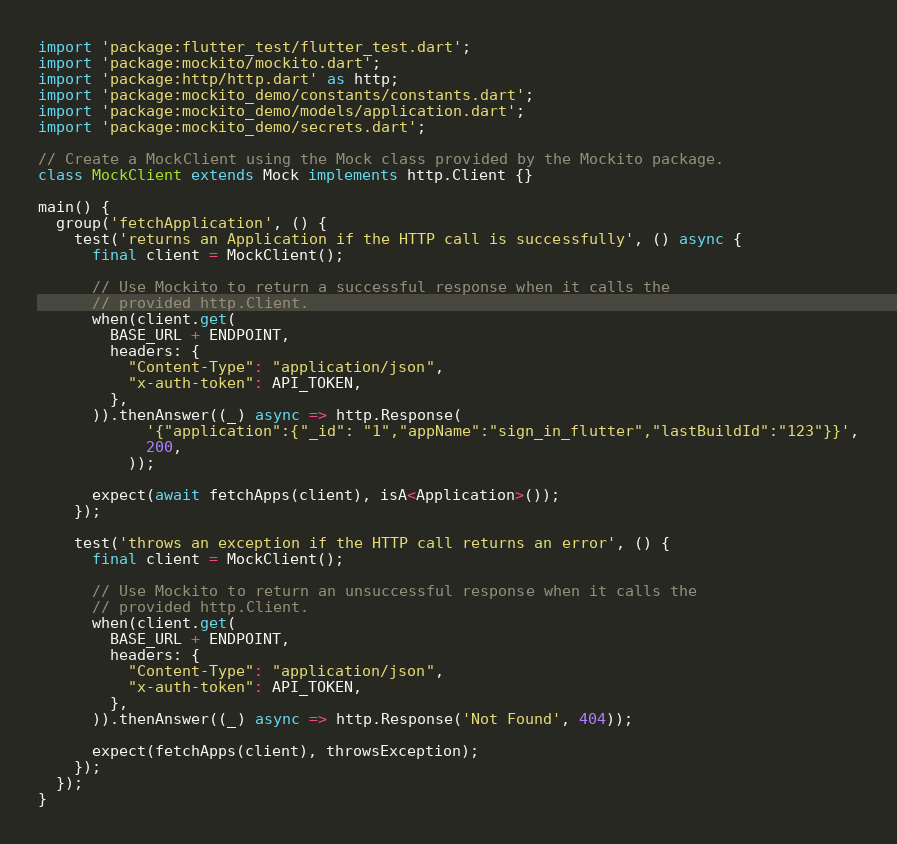<code> <loc_0><loc_0><loc_500><loc_500><_Dart_>import 'package:flutter_test/flutter_test.dart';
import 'package:mockito/mockito.dart';
import 'package:http/http.dart' as http;
import 'package:mockito_demo/constants/constants.dart';
import 'package:mockito_demo/models/application.dart';
import 'package:mockito_demo/secrets.dart';

// Create a MockClient using the Mock class provided by the Mockito package.
class MockClient extends Mock implements http.Client {}

main() {
  group('fetchApplication', () {
    test('returns an Application if the HTTP call is successfully', () async {
      final client = MockClient();

      // Use Mockito to return a successful response when it calls the
      // provided http.Client.
      when(client.get(
        BASE_URL + ENDPOINT,
        headers: {
          "Content-Type": "application/json",
          "x-auth-token": API_TOKEN,
        },
      )).thenAnswer((_) async => http.Response(
            '{"application":{"_id": "1","appName":"sign_in_flutter","lastBuildId":"123"}}',
            200,
          ));

      expect(await fetchApps(client), isA<Application>());
    });

    test('throws an exception if the HTTP call returns an error', () {
      final client = MockClient();

      // Use Mockito to return an unsuccessful response when it calls the
      // provided http.Client.
      when(client.get(
        BASE_URL + ENDPOINT,
        headers: {
          "Content-Type": "application/json",
          "x-auth-token": API_TOKEN,
        },
      )).thenAnswer((_) async => http.Response('Not Found', 404));

      expect(fetchApps(client), throwsException);
    });
  });
}
</code> 